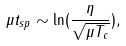Convert formula to latex. <formula><loc_0><loc_0><loc_500><loc_500>\mu t _ { s p } \sim \ln ( \frac { \eta } { \sqrt { \mu T _ { c } } } ) ,</formula> 